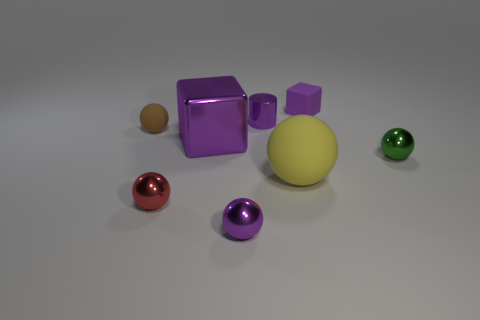Are there the same number of tiny matte balls that are behind the small green ball and cyan balls?
Ensure brevity in your answer.  No. Do the yellow rubber thing and the metal cylinder have the same size?
Provide a succinct answer. No. There is a small matte object that is right of the purple block that is to the left of the yellow matte sphere; are there any big yellow balls to the right of it?
Keep it short and to the point. No. What is the material of the yellow object that is the same shape as the small green shiny thing?
Your answer should be compact. Rubber. There is a tiny metal sphere that is behind the yellow matte thing; what number of big blocks are in front of it?
Keep it short and to the point. 0. There is a matte thing that is in front of the tiny ball right of the large object right of the shiny cube; what is its size?
Your answer should be compact. Large. The rubber thing right of the matte ball in front of the green ball is what color?
Your answer should be compact. Purple. How many other things are there of the same material as the large ball?
Your answer should be compact. 2. How many other objects are the same color as the tiny rubber ball?
Give a very brief answer. 0. What is the material of the block that is to the left of the small rubber object on the right side of the small purple metal ball?
Offer a terse response. Metal. 